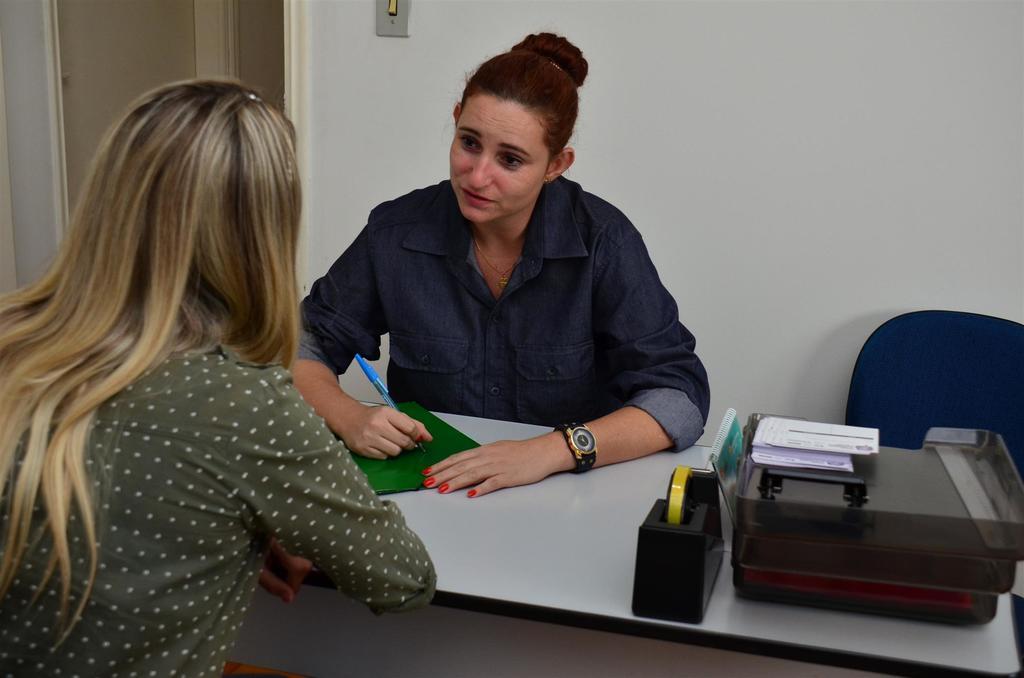How would you summarize this image in a sentence or two? The image is clicked inside the room. In this image there are two women. In the middle, the woman is wearing blue color shirt. To the left, the woman is wearing a gray color shirt. In the background, there is switch, door and which color wall. In the front there is a table, on which a tape stand and a box is kept. 